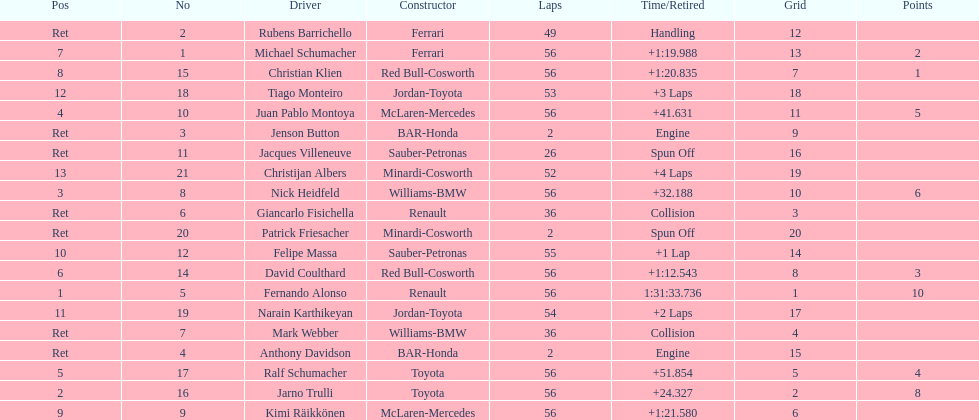How many drivers completed the race early because of engine troubles? 2. 